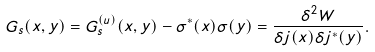Convert formula to latex. <formula><loc_0><loc_0><loc_500><loc_500>G _ { s } ( x , y ) = G ^ { ( u ) } _ { s } ( x , y ) - \sigma ^ { * } ( x ) \sigma ( y ) = \frac { \delta ^ { 2 } W } { \delta j ( x ) \delta j ^ { * } ( y ) } .</formula> 